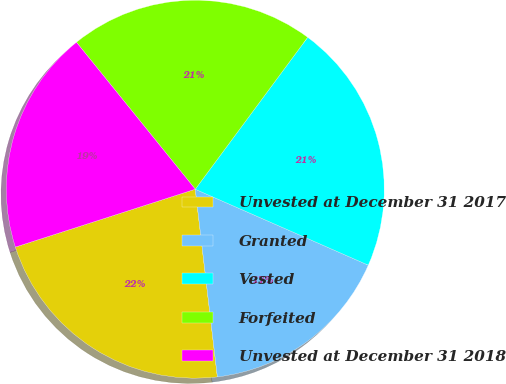<chart> <loc_0><loc_0><loc_500><loc_500><pie_chart><fcel>Unvested at December 31 2017<fcel>Granted<fcel>Vested<fcel>Forfeited<fcel>Unvested at December 31 2018<nl><fcel>21.91%<fcel>16.55%<fcel>21.44%<fcel>20.96%<fcel>19.13%<nl></chart> 